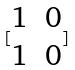Convert formula to latex. <formula><loc_0><loc_0><loc_500><loc_500>[ \begin{matrix} 1 & 0 \\ 1 & 0 \end{matrix} ]</formula> 